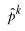Convert formula to latex. <formula><loc_0><loc_0><loc_500><loc_500>\hat { p } ^ { k }</formula> 